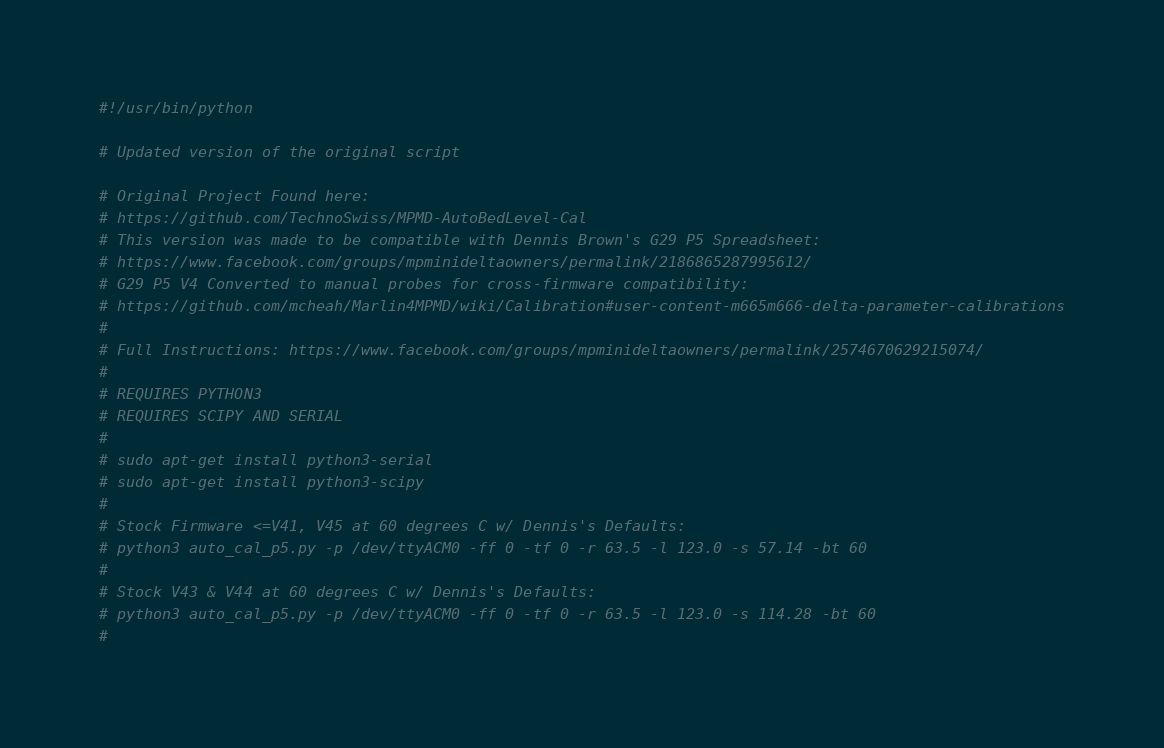Convert code to text. <code><loc_0><loc_0><loc_500><loc_500><_Python_>#!/usr/bin/python

# Updated version of the original script

# Original Project Found here:
# https://github.com/TechnoSwiss/MPMD-AutoBedLevel-Cal
# This version was made to be compatible with Dennis Brown's G29 P5 Spreadsheet:
# https://www.facebook.com/groups/mpminideltaowners/permalink/2186865287995612/
# G29 P5 V4 Converted to manual probes for cross-firmware compatibility:
# https://github.com/mcheah/Marlin4MPMD/wiki/Calibration#user-content-m665m666-delta-parameter-calibrations
#
# Full Instructions: https://www.facebook.com/groups/mpminideltaowners/permalink/2574670629215074/
#
# REQUIRES PYTHON3
# REQUIRES SCIPY AND SERIAL
#
# sudo apt-get install python3-serial
# sudo apt-get install python3-scipy
#
# Stock Firmware <=V41, V45 at 60 degrees C w/ Dennis's Defaults:
# python3 auto_cal_p5.py -p /dev/ttyACM0 -ff 0 -tf 0 -r 63.5 -l 123.0 -s 57.14 -bt 60
#
# Stock V43 & V44 at 60 degrees C w/ Dennis's Defaults:
# python3 auto_cal_p5.py -p /dev/ttyACM0 -ff 0 -tf 0 -r 63.5 -l 123.0 -s 114.28 -bt 60
#</code> 